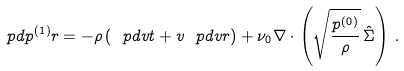Convert formula to latex. <formula><loc_0><loc_0><loc_500><loc_500>\ p d { p ^ { ( 1 ) } } { r } = - \rho \left ( \ p d { v } { t } + v \ p d { v } { r } \right ) + \nu _ { 0 } \nabla \cdot \left ( \sqrt { \frac { p ^ { ( 0 ) } } { \rho } } \, \hat { \Sigma } \right ) \, .</formula> 